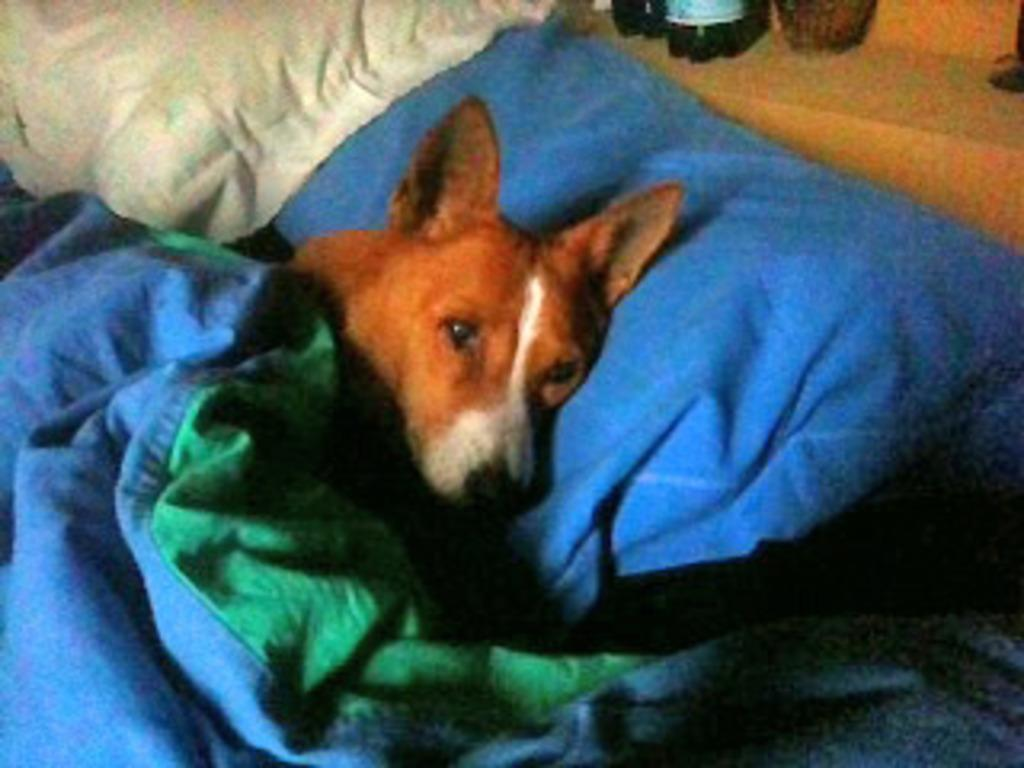What type of animal is in the image? There is a dog in the image. What is the dog doing in the image? The dog is lying on a pillow. How is the pillow decorated or covered? The pillow is covered with a blanket. What type of songs can be heard in the background of the image? There are no songs or sounds present in the image, as it is a still photograph. 